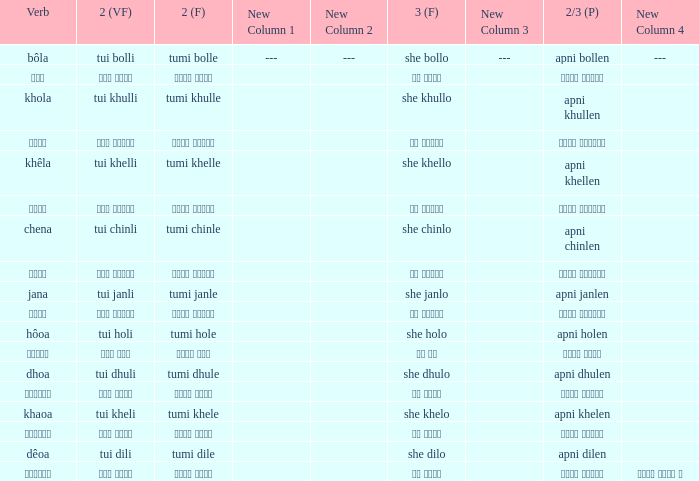What is the 3rd for the 2nd Tui Dhuli? She dhulo. 